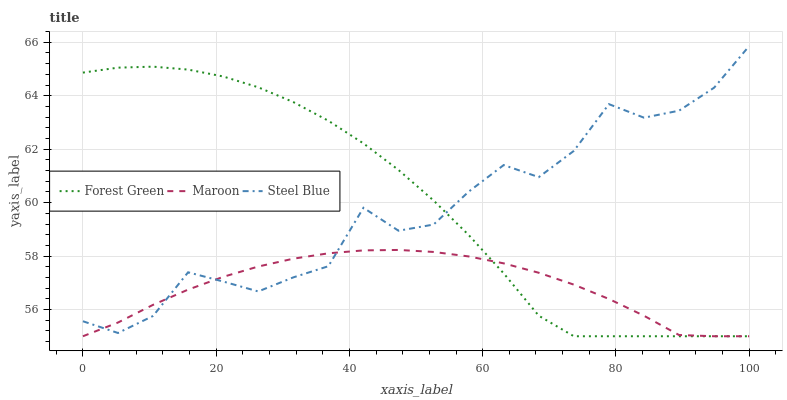Does Steel Blue have the minimum area under the curve?
Answer yes or no. No. Does Steel Blue have the maximum area under the curve?
Answer yes or no. No. Is Steel Blue the smoothest?
Answer yes or no. No. Is Maroon the roughest?
Answer yes or no. No. Does Steel Blue have the lowest value?
Answer yes or no. No. Does Maroon have the highest value?
Answer yes or no. No. 